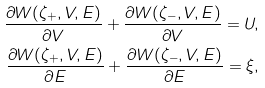<formula> <loc_0><loc_0><loc_500><loc_500>\frac { \partial { W ( \zeta _ { + } , V , E ) } } { \partial { V } } + \frac { \partial { W ( \zeta _ { - } , V , E ) } } { \partial { V } } = U , \\ \frac { \partial { W ( \zeta _ { + } , V , E ) } } { \partial { E } } + \frac { \partial { W ( \zeta _ { - } , V , E ) } } { \partial { E } } = \xi ,</formula> 